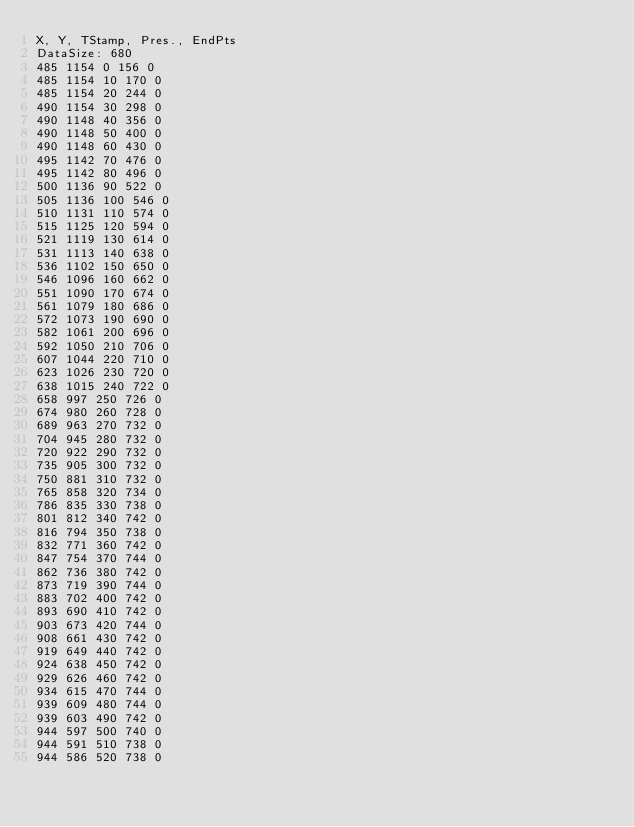<code> <loc_0><loc_0><loc_500><loc_500><_SML_>X, Y, TStamp, Pres., EndPts
DataSize: 680
485 1154 0 156 0
485 1154 10 170 0
485 1154 20 244 0
490 1154 30 298 0
490 1148 40 356 0
490 1148 50 400 0
490 1148 60 430 0
495 1142 70 476 0
495 1142 80 496 0
500 1136 90 522 0
505 1136 100 546 0
510 1131 110 574 0
515 1125 120 594 0
521 1119 130 614 0
531 1113 140 638 0
536 1102 150 650 0
546 1096 160 662 0
551 1090 170 674 0
561 1079 180 686 0
572 1073 190 690 0
582 1061 200 696 0
592 1050 210 706 0
607 1044 220 710 0
623 1026 230 720 0
638 1015 240 722 0
658 997 250 726 0
674 980 260 728 0
689 963 270 732 0
704 945 280 732 0
720 922 290 732 0
735 905 300 732 0
750 881 310 732 0
765 858 320 734 0
786 835 330 738 0
801 812 340 742 0
816 794 350 738 0
832 771 360 742 0
847 754 370 744 0
862 736 380 742 0
873 719 390 744 0
883 702 400 742 0
893 690 410 742 0
903 673 420 744 0
908 661 430 742 0
919 649 440 742 0
924 638 450 742 0
929 626 460 742 0
934 615 470 744 0
939 609 480 744 0
939 603 490 742 0
944 597 500 740 0
944 591 510 738 0
944 586 520 738 0</code> 